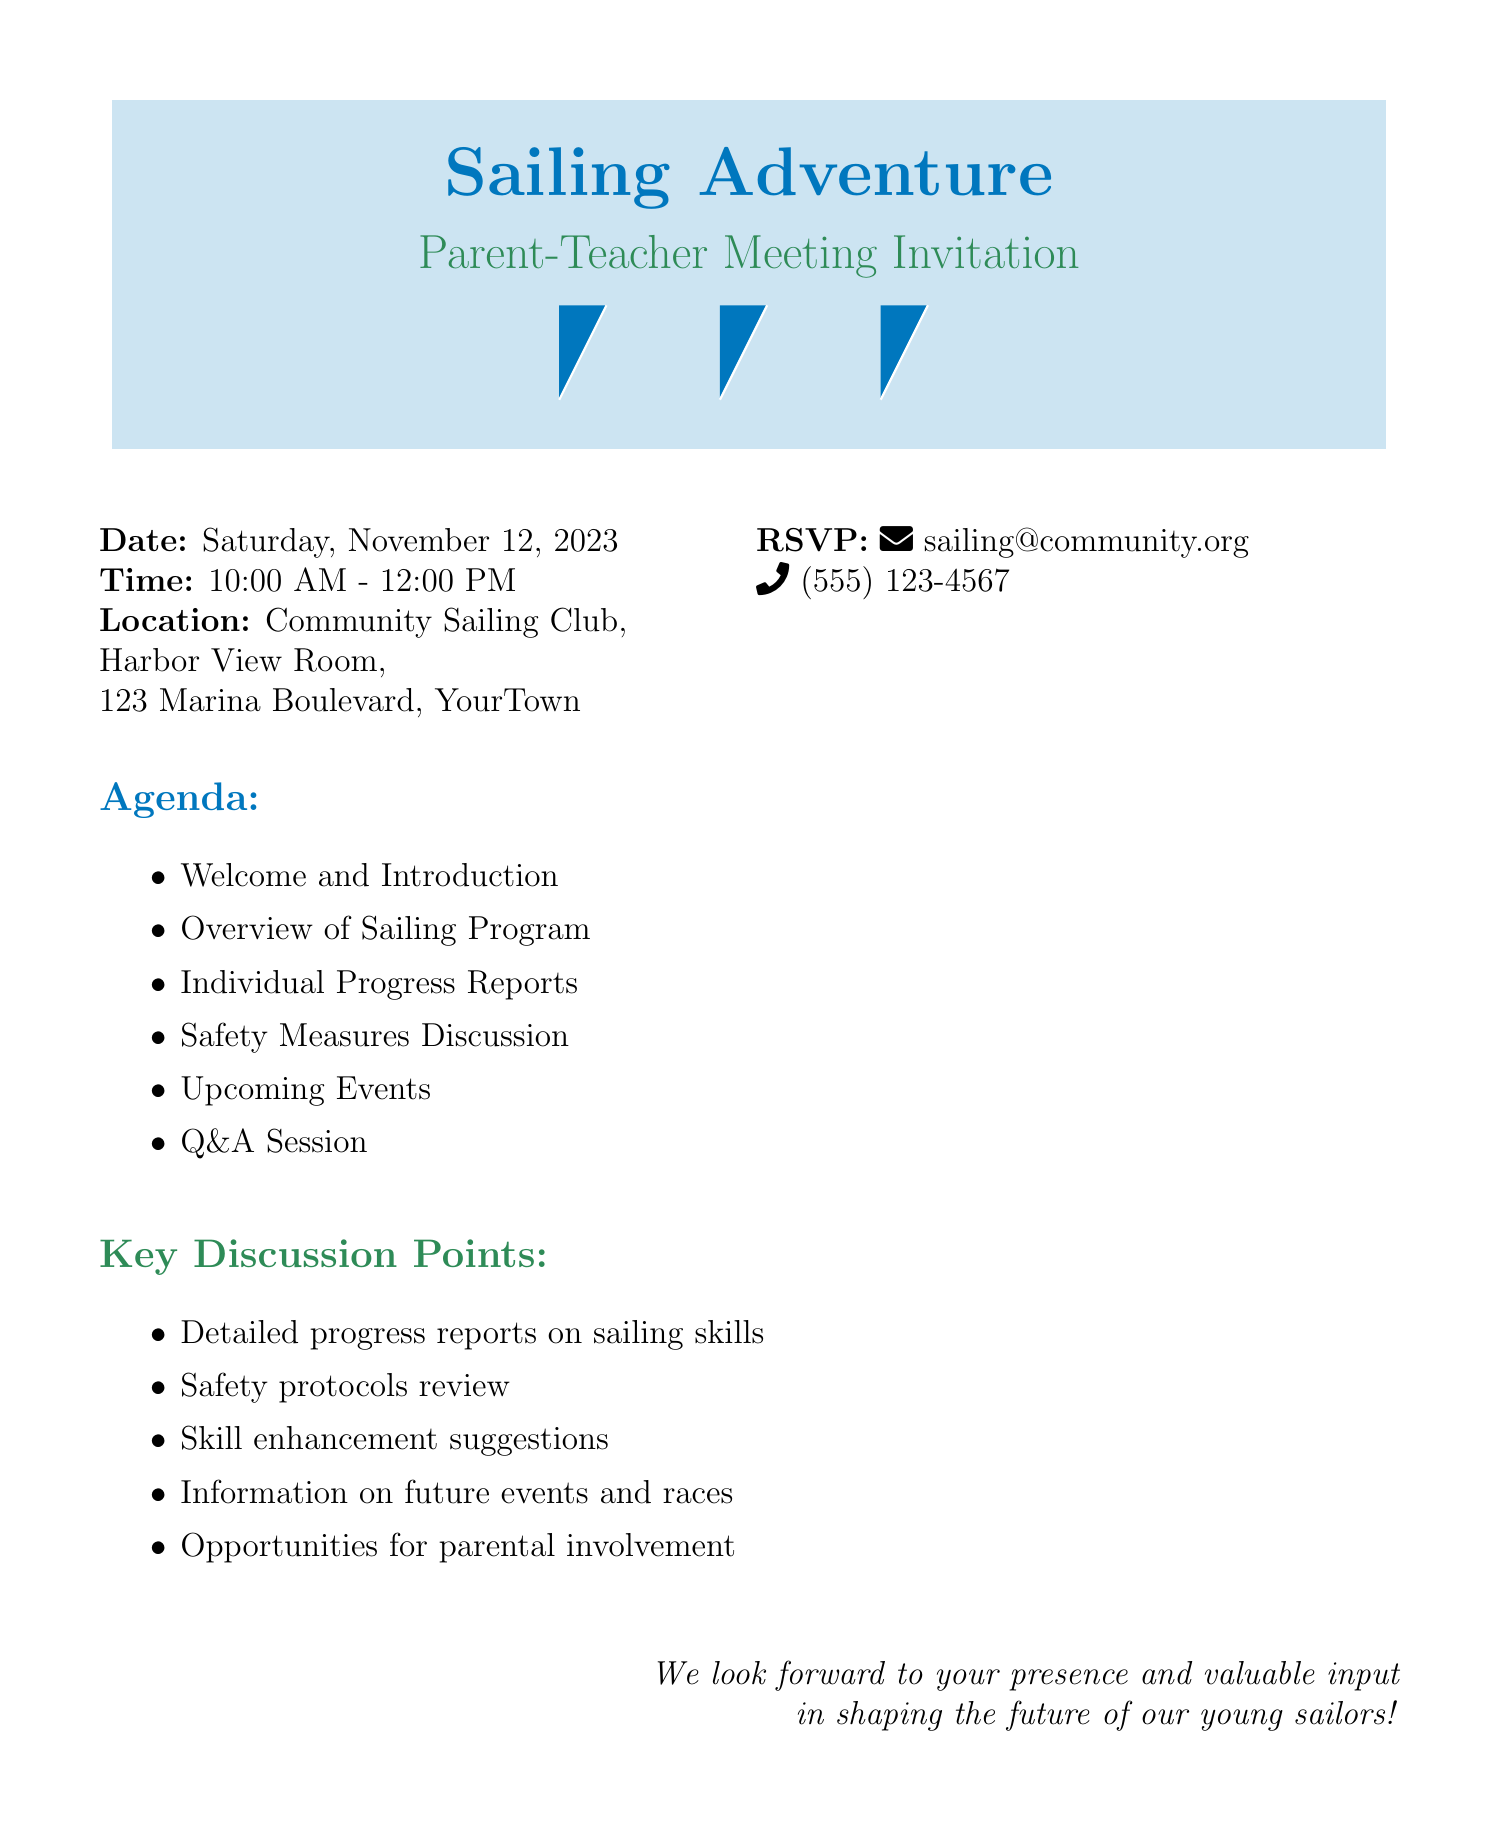What is the date of the meeting? The date is explicitly mentioned in the document as Saturday, November 12, 2023.
Answer: Saturday, November 12, 2023 What is the time of the meeting? The time range for the meeting is given in the document as 10:00 AM - 12:00 PM.
Answer: 10:00 AM - 12:00 PM Where is the meeting located? The location is detailed in the document as Community Sailing Club, Harbor View Room, 123 Marina Boulevard, YourTown.
Answer: Community Sailing Club, Harbor View Room, 123 Marina Boulevard, YourTown What is one of the key discussion points? The document lists key discussion points, one of which is detailed progress reports on sailing skills.
Answer: Detailed progress reports on sailing skills What is the RSVP email address? The RSVP email is clearly provided in the document as sailing@community.org.
Answer: sailing@community.org What kind of input is expected from parents? The closing statement of the document indicates that valuable input is expected from parents to shape the future of young sailors.
Answer: Valuable input How many items are in the agenda? The agenda lists a total of six items in the meeting.
Answer: Six items What aspect of the sailing program will be reviewed? The document specifies that safety protocols will be reviewed during the meeting.
Answer: Safety protocols What is emphasized as the mission of the Community Sailing Program? The mission is briefly stated at the bottom of the document as nurturing young sailors, one wave at a time.
Answer: Nurturing young sailors, one wave at a time 